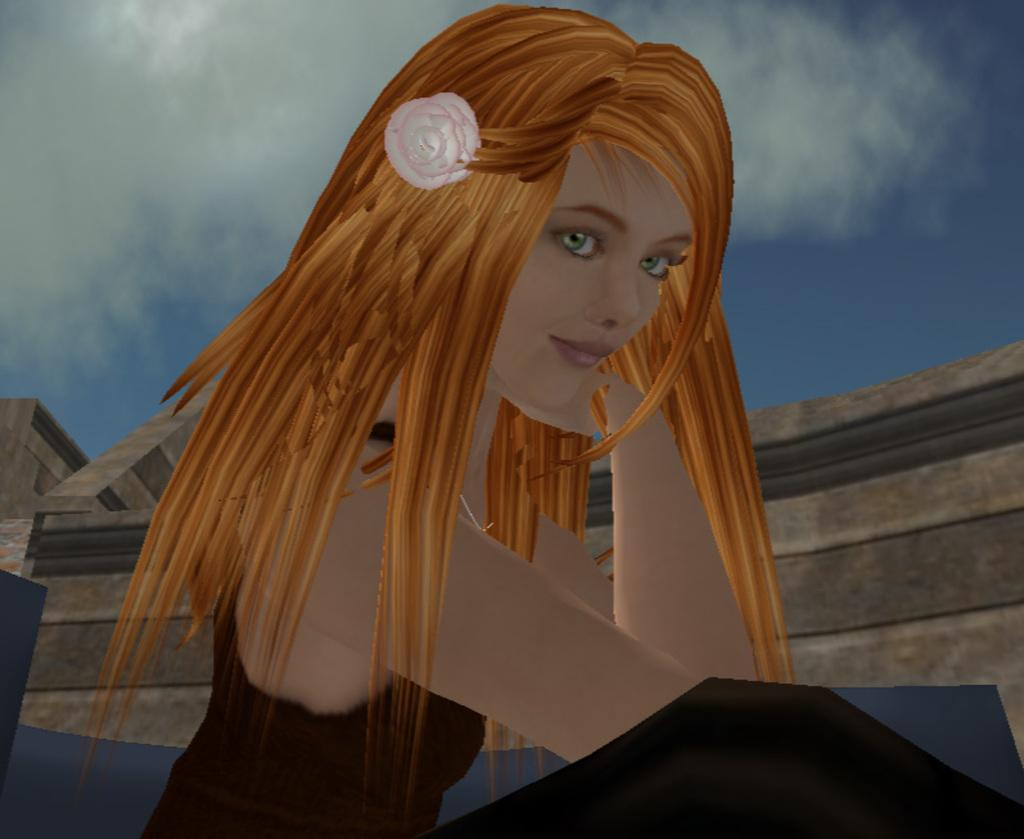What is the main subject of the picture? The main subject of the picture is a graphical image of a woman. What is the woman wearing in the image? The woman is wearing a black dress in the image. What can be seen in the background of the image? The background of the image includes a cloudy sky. How many cakes are displayed on the table in the image? There are no cakes or tables present in the image; it features a graphical image of a woman with a cloudy sky background. 